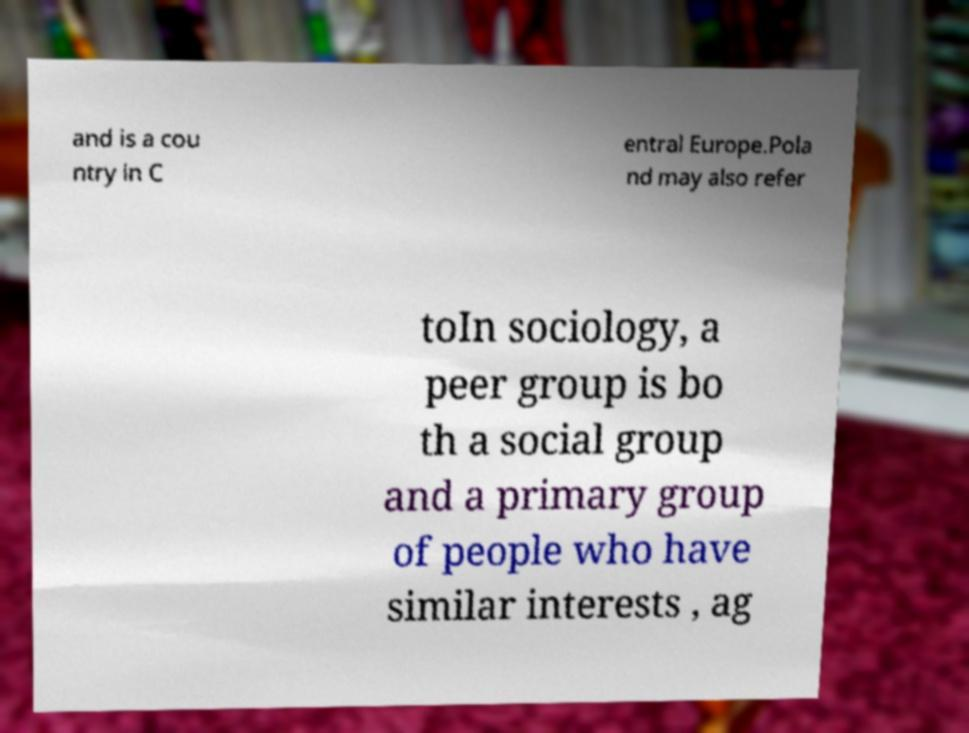I need the written content from this picture converted into text. Can you do that? and is a cou ntry in C entral Europe.Pola nd may also refer toIn sociology, a peer group is bo th a social group and a primary group of people who have similar interests , ag 